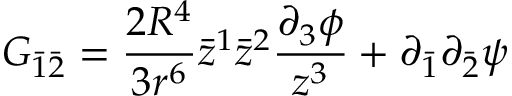<formula> <loc_0><loc_0><loc_500><loc_500>G _ { \bar { 1 } \bar { 2 } } = \frac { 2 R ^ { 4 } } { 3 r ^ { 6 } } \bar { z } ^ { 1 } \bar { z } ^ { 2 } \frac { \partial _ { 3 } \phi } { z ^ { 3 } } + \partial _ { \bar { 1 } } \partial _ { \bar { 2 } } \psi</formula> 